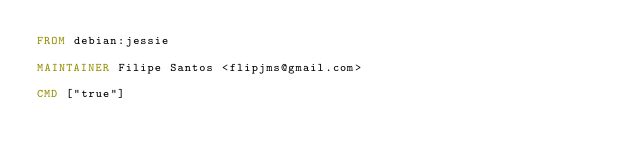Convert code to text. <code><loc_0><loc_0><loc_500><loc_500><_Dockerfile_>FROM debian:jessie

MAINTAINER Filipe Santos <flipjms@gmail.com>

CMD ["true"]
</code> 